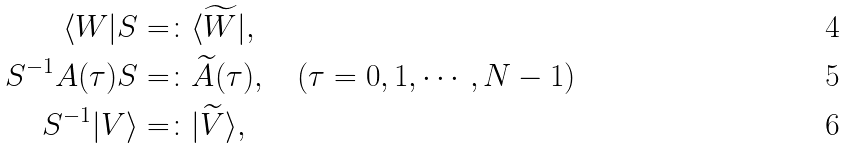<formula> <loc_0><loc_0><loc_500><loc_500>\langle W | S & = \colon \langle \widetilde { W } | , \\ S ^ { - 1 } A ( \tau ) S & = \colon \widetilde { A } ( \tau ) , \quad ( \tau = 0 , 1 , \cdots , N - 1 ) \\ S ^ { - 1 } | V \rangle & = \colon | \widetilde { V } \rangle ,</formula> 